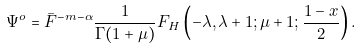Convert formula to latex. <formula><loc_0><loc_0><loc_500><loc_500>\Psi ^ { o } = { \bar { F } } ^ { - m - \alpha } \frac { 1 } { \Gamma ( 1 + \mu ) } F _ { H } \left ( - \lambda , \lambda + 1 ; \mu + 1 ; \frac { 1 - x } { 2 } \right ) .</formula> 